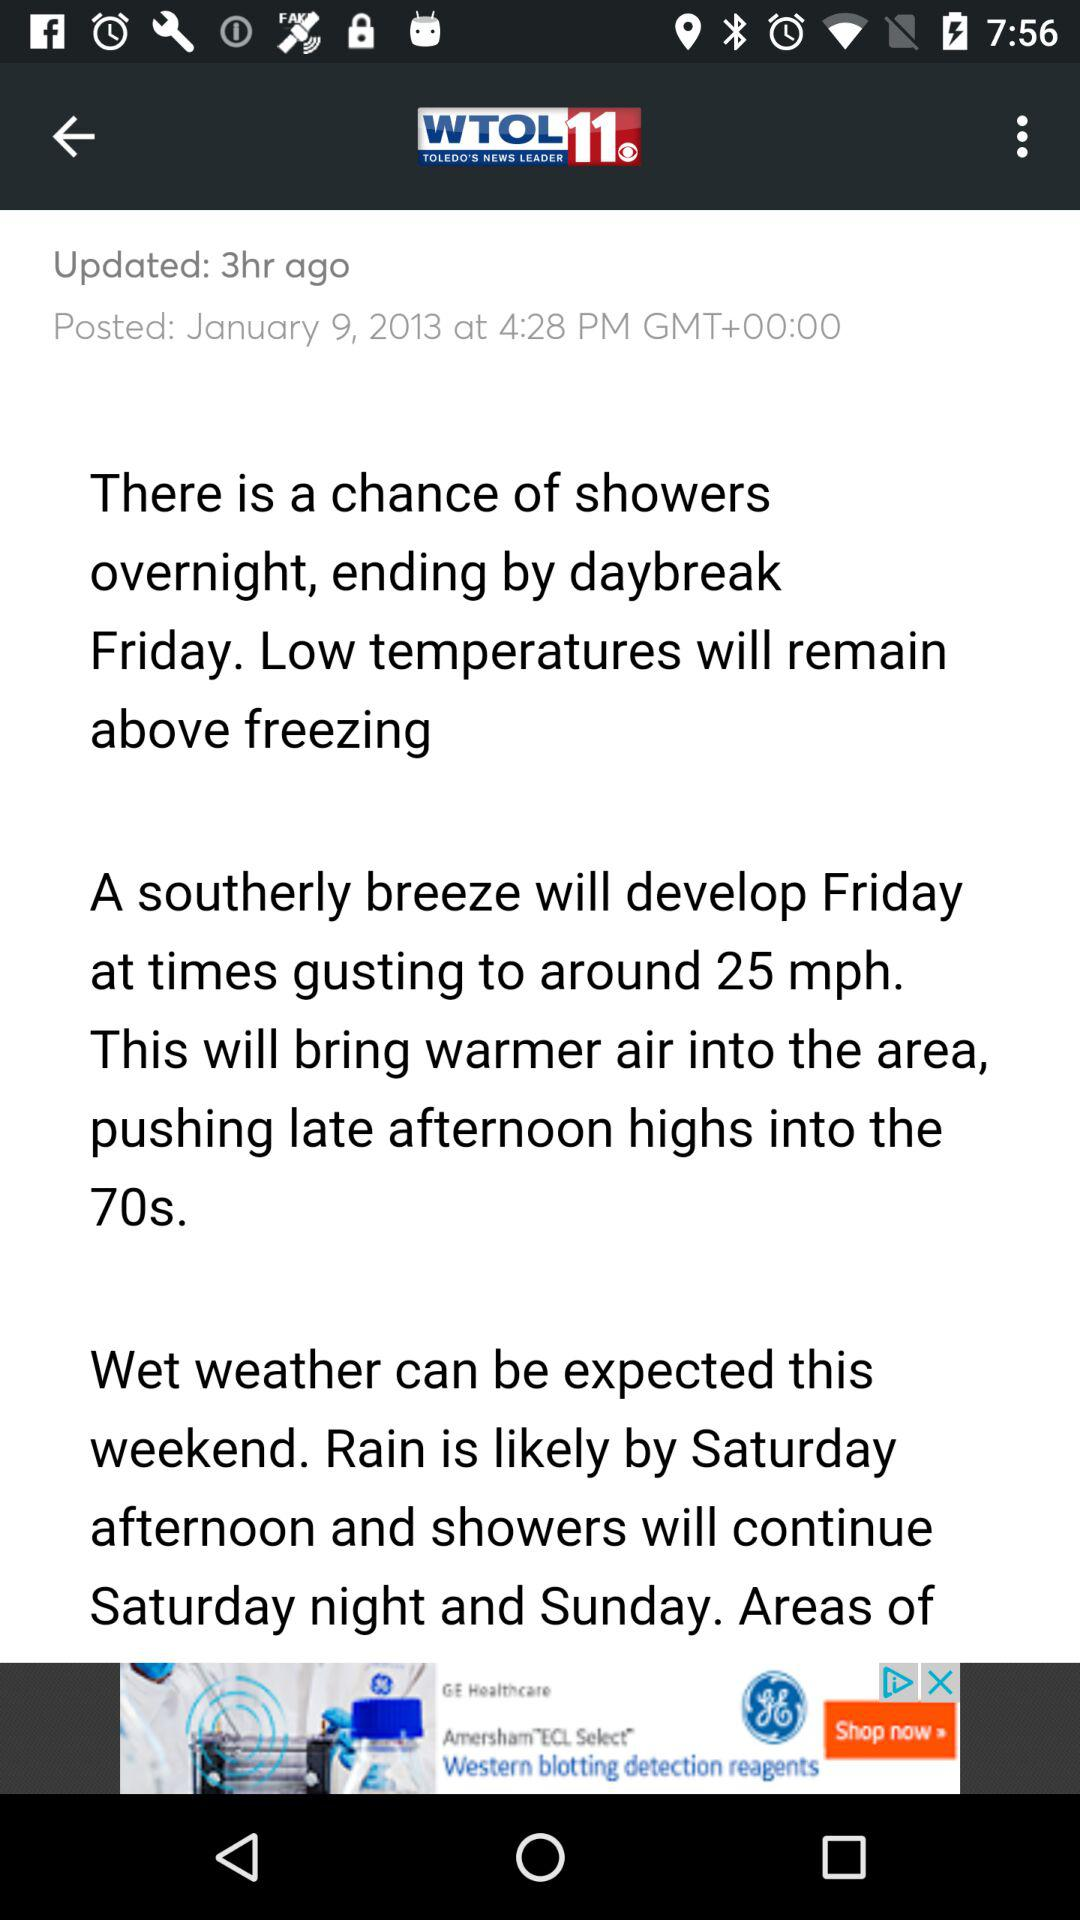How many hours ago was the weather updated?
Answer the question using a single word or phrase. 3 